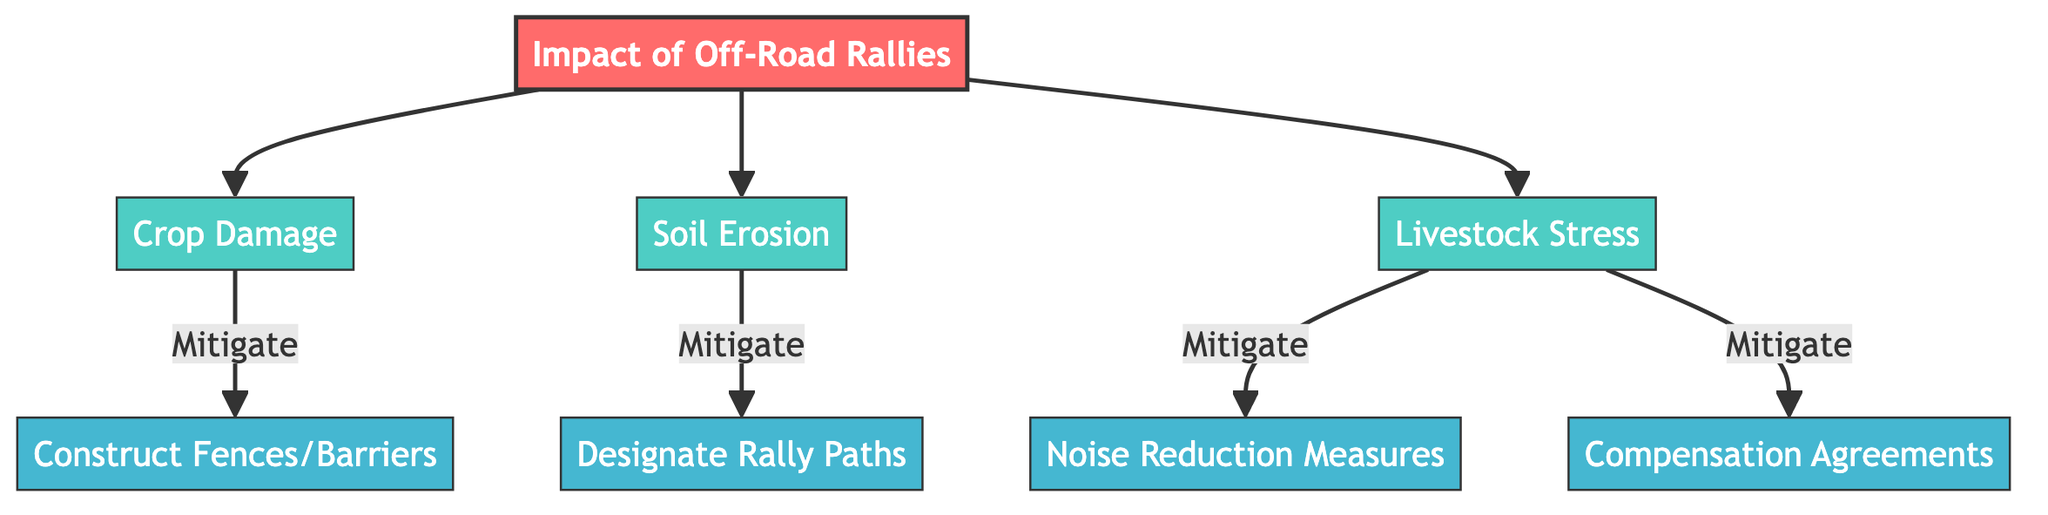What are the three impacts of off-road rallies shown in the diagram? The diagram displays three impacts: Crop Damage, Soil Erosion, and Livestock Stress, which are connected to the central node of Off-Road Rallies' Impact.
Answer: Crop Damage, Soil Erosion, Livestock Stress How many mitigation strategies are listed in the diagram? There are four mitigation strategies mentioned: Construct Fences/Barriers, Designate Rally Paths, Compensation Agreements, and Noise Reduction Measures. Each of these strategies directs from the impacts of rallies.
Answer: Four Which impact is directly linked to constructing fences/barriers? The diagram shows that Crop Damage is the only impact that has a direct link to the mitigation strategy of Construct Fences/Barriers, indicated by the arrow connecting them.
Answer: Crop Damage From which impact does the strategy of designating rally paths derive? The strategy of Designating Rally Paths comes from the Soil Erosion impact, as indicated by the arrow connecting these two nodes in the diagram.
Answer: Soil Erosion What two mitigation strategies are associated with livestock stress according to the diagram? The two strategies connected to Livestock Stress are Noise Reduction Measures and Compensation Agreements, both of which stem from the Livestock Stress node.
Answer: Noise Reduction Measures, Compensation Agreements If crop damage is mitigated, which physical measure is suggested in the diagram? The diagram specifies that constructing fences or barriers is the suggested physical measure to mitigate crop damage, as indicated by the flow from Crop Damage to Construct Fences/Barriers.
Answer: Construct Fences/Barriers Which impact leads to the need for noise reduction measures in the diagram? The diagram indicates that Livestock Stress leads to the need for Noise Reduction Measures, as it is the only path that connects these two nodes.
Answer: Livestock Stress How are the impacts of off-road rallies connected to the mitigation strategies? Each impact (Crop Damage, Soil Erosion, and Livestock Stress) has its own mitigation strategies connecting them, with specific strategies influencing each impact separately as depicted in the flow of the diagram.
Answer: Each impact has its own strategies 